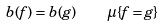Convert formula to latex. <formula><loc_0><loc_0><loc_500><loc_500>b ( f ) = b ( g ) \quad \mu \{ f = g \}</formula> 